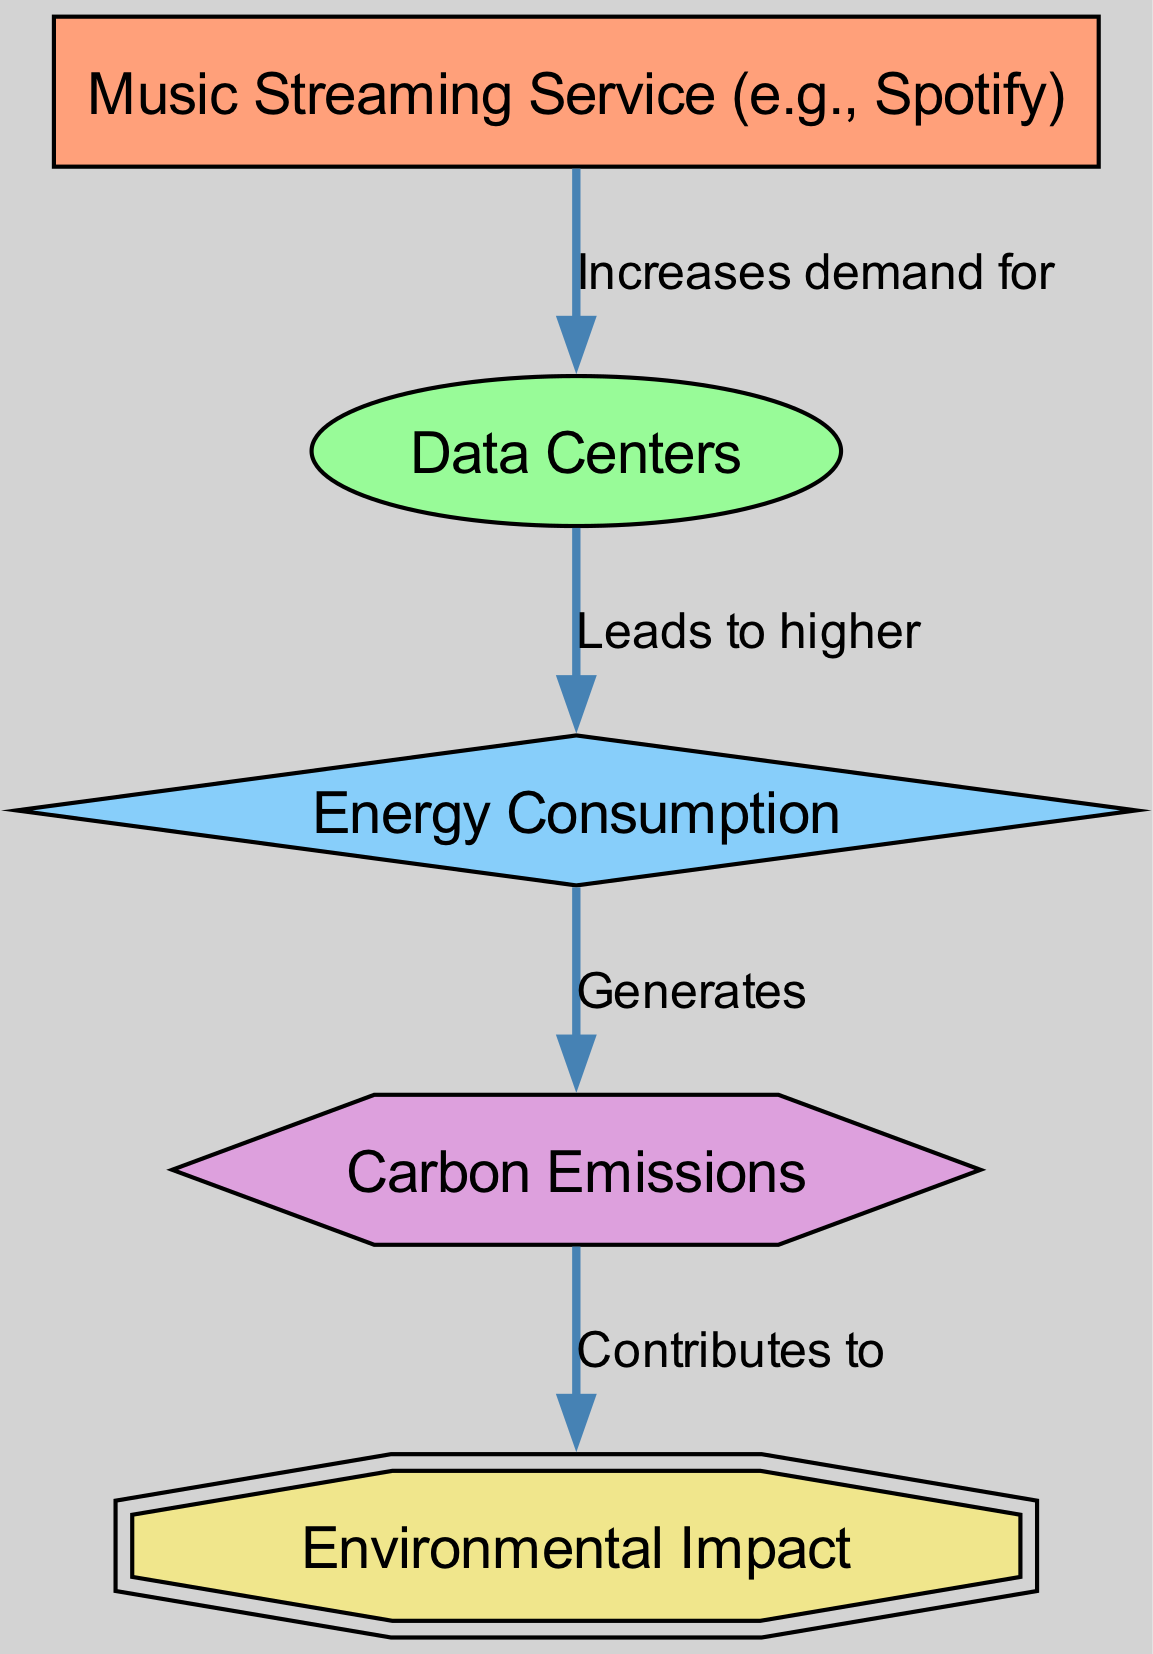What is the primary producer in the diagram? The primary producer, which initiates the food chain, is the "Music Streaming Service (e.g., Spotify)." This is the first element listed and marked as a producer in the diagram.
Answer: Music Streaming Service (e.g., Spotify) How many nodes are present in the diagram? The diagram contains five nodes, counting each unique element: the streaming service, the data center, energy consumption, carbon emissions, and environmental impact.
Answer: 5 What does the data center lead to? The data center leads to "higher energy consumption," as indicated by the relationship connecting these two elements in the diagram.
Answer: Higher energy consumption Which element is contributed to by carbon emissions? The "Environmental Impact" is the element that is contributed to by the carbon emissions, as the diagram shows a directed edge from carbon emissions to environmental impact.
Answer: Environmental Impact What is the flow direction from energy consumption to carbon emissions? The flow direction from energy consumption to carbon emissions is indicated by an arrow that signifies that energy consumption generates carbon emissions, establishing a cause-effect relationship between the two.
Answer: Generates What type of consumer is the environmental impact in this diagram? The environmental impact is an "apex consumer," designed to represent the ultimate outcome of the prior relationships defined in the diagram.
Answer: Apex consumer What is the relationship label between the streaming service and data center? The relationship label between the streaming service and data center is "Increases demand for," indicating that the streaming service drives the need for data center resources.
Answer: Increases demand for What kind of impact does carbon emissions have as the tertiary consumer? The carbon emissions contribute to "Environmental Impact," indicating that as they increase, they worsen the overall impact on the environment. This represents a cumulative effect as shown in the directed relationships.
Answer: Contributes to What is the status of the energy consumption in the hierarchy of consumers? Energy consumption is a "secondary consumer" in the hierarchy, meaning it acts as a middle layer influenced by the primary consumer, the data center, and impacting the tertiary consumer, carbon emissions.
Answer: Secondary consumer 